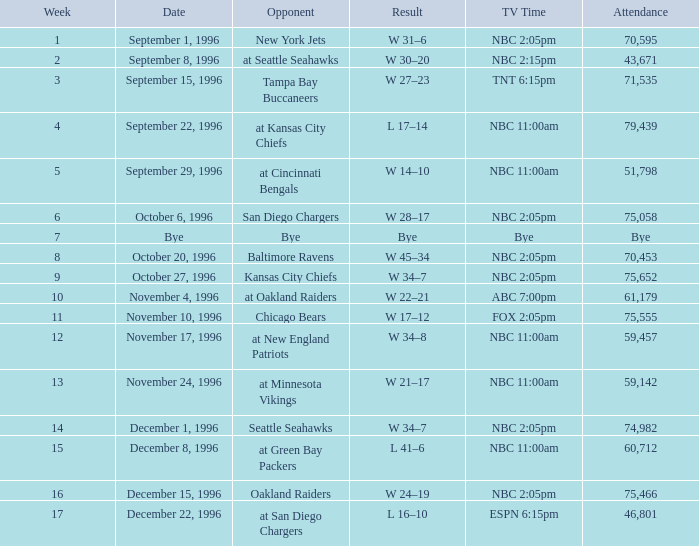What is the consequence when the adversary was chicago bears? W 17–12. 